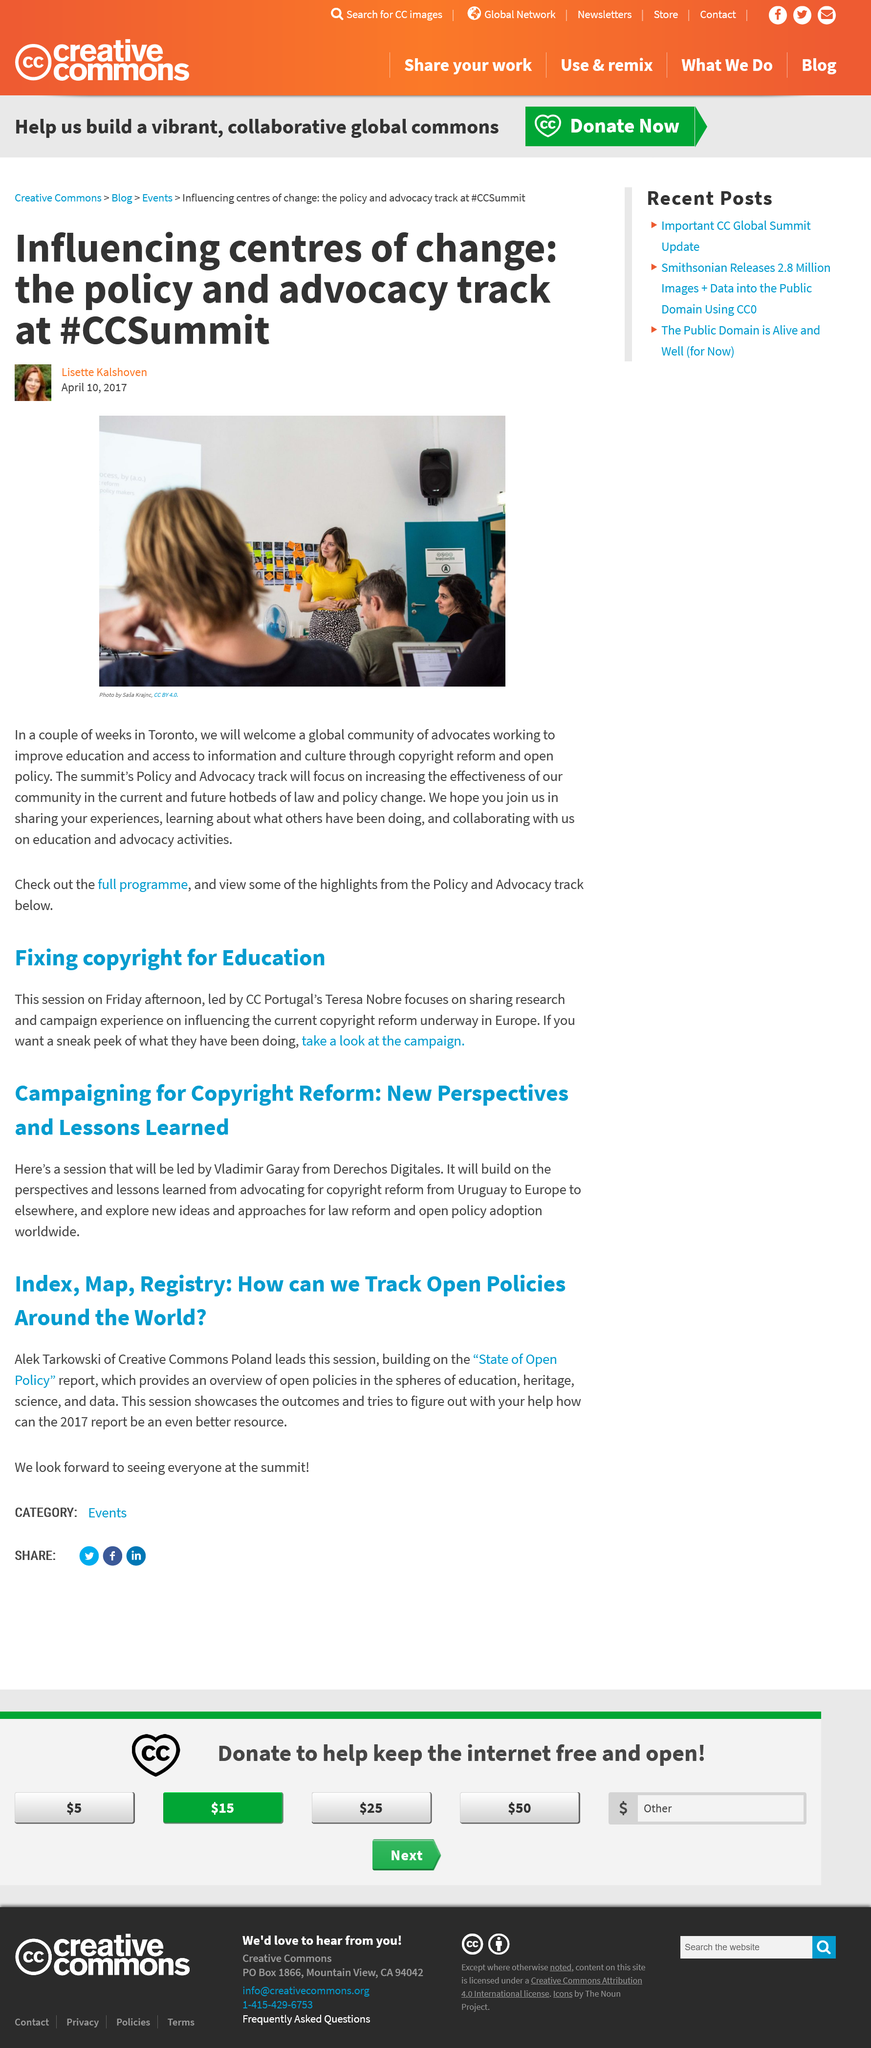Give some essential details in this illustration. The Creative Commons Poland was led by Alek Tarkowski during the session. The location of the #CCSummit is Toronto. The topic that Vladimir Garay was discussing in this article is copyright reform. The State of Open Policy provides an overview of policies related to education, heritage, science, and data that are open and accessible to the public. The report mentioned is built upon by Alek Tarkowski's State of Open Policy report. 